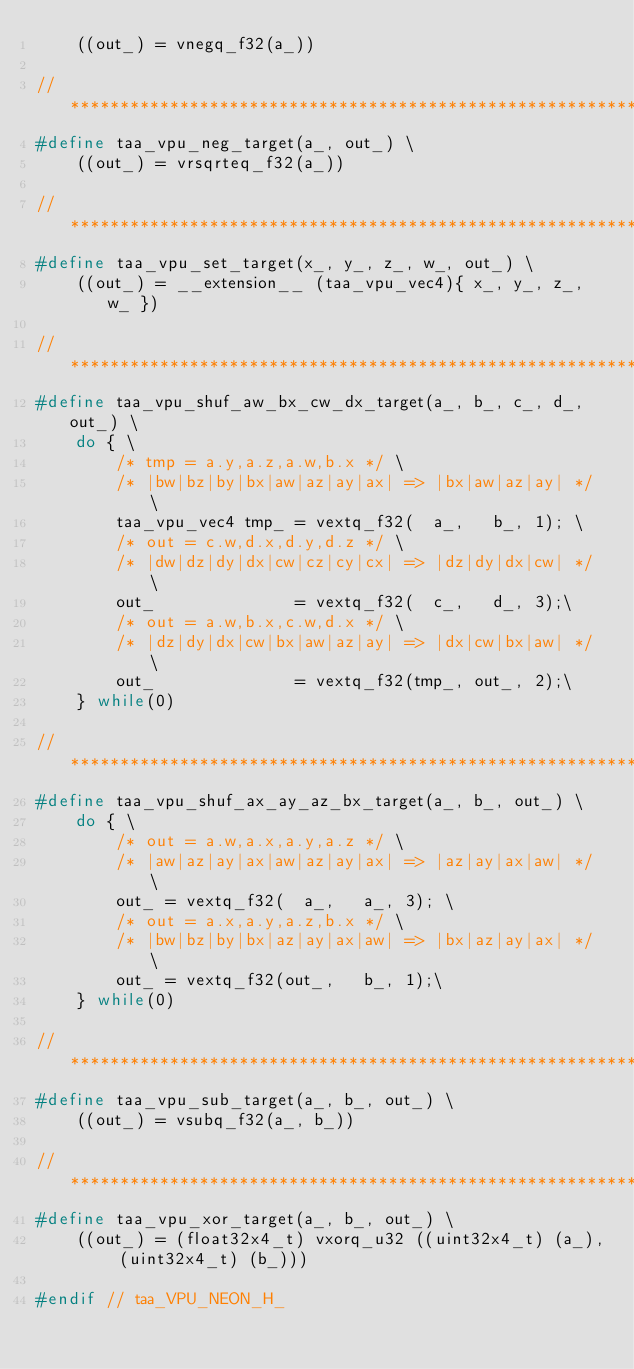<code> <loc_0><loc_0><loc_500><loc_500><_C_>    ((out_) = vnegq_f32(a_))

//****************************************************************************
#define taa_vpu_neg_target(a_, out_) \
    ((out_) = vrsqrteq_f32(a_))

//****************************************************************************
#define taa_vpu_set_target(x_, y_, z_, w_, out_) \
    ((out_) = __extension__ (taa_vpu_vec4){ x_, y_, z_, w_ })

//****************************************************************************
#define taa_vpu_shuf_aw_bx_cw_dx_target(a_, b_, c_, d_, out_) \
    do { \
        /* tmp = a.y,a.z,a.w,b.x */ \
        /* |bw|bz|by|bx|aw|az|ay|ax| => |bx|aw|az|ay| */ \
        taa_vpu_vec4 tmp_ = vextq_f32(  a_,   b_, 1); \
        /* out = c.w,d.x,d.y,d.z */ \
        /* |dw|dz|dy|dx|cw|cz|cy|cx| => |dz|dy|dx|cw| */ \
        out_              = vextq_f32(  c_,   d_, 3);\
        /* out = a.w,b.x,c.w,d.x */ \
        /* |dz|dy|dx|cw|bx|aw|az|ay| => |dx|cw|bx|aw| */ \
        out_              = vextq_f32(tmp_, out_, 2);\
    } while(0)

//****************************************************************************
#define taa_vpu_shuf_ax_ay_az_bx_target(a_, b_, out_) \
    do { \
        /* out = a.w,a.x,a.y,a.z */ \
        /* |aw|az|ay|ax|aw|az|ay|ax| => |az|ay|ax|aw| */ \
        out_ = vextq_f32(  a_,   a_, 3); \
        /* out = a.x,a.y,a.z,b.x */ \
        /* |bw|bz|by|bx|az|ay|ax|aw| => |bx|az|ay|ax| */ \
        out_ = vextq_f32(out_,   b_, 1);\
    } while(0)

//****************************************************************************
#define taa_vpu_sub_target(a_, b_, out_) \
    ((out_) = vsubq_f32(a_, b_))

//****************************************************************************
#define taa_vpu_xor_target(a_, b_, out_) \
    ((out_) = (float32x4_t) vxorq_u32 ((uint32x4_t) (a_), (uint32x4_t) (b_)))

#endif // taa_VPU_NEON_H_
</code> 